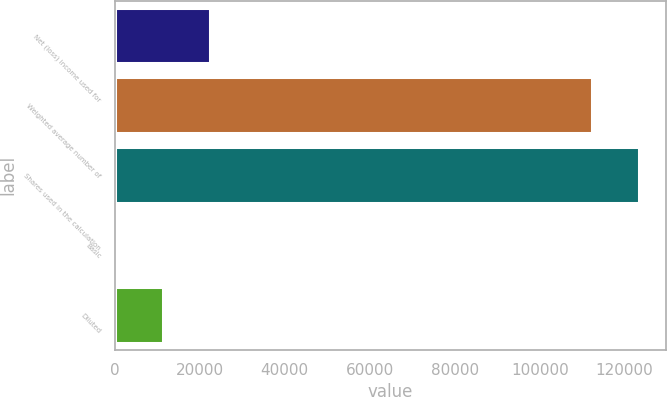Convert chart to OTSL. <chart><loc_0><loc_0><loc_500><loc_500><bar_chart><fcel>Net (loss) income used for<fcel>Weighted average number of<fcel>Shares used in the calculation<fcel>Basic<fcel>Diluted<nl><fcel>22450.6<fcel>112253<fcel>123478<fcel>0.02<fcel>11225.3<nl></chart> 